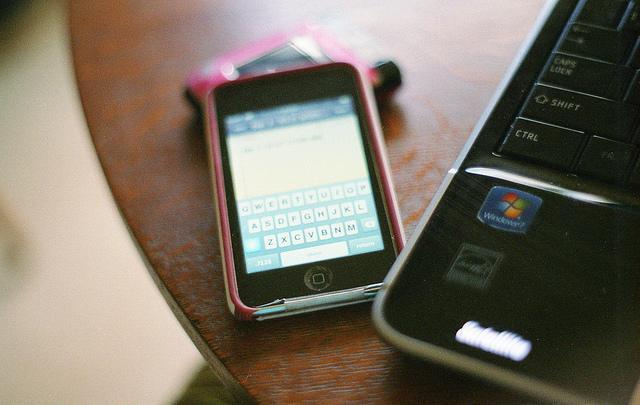How many hands are in the photo?
Give a very brief answer. 0. How many cell phones are in the photo?
Give a very brief answer. 3. 